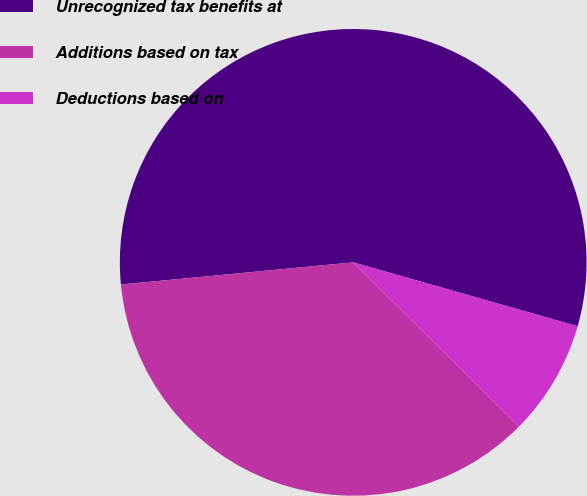Convert chart. <chart><loc_0><loc_0><loc_500><loc_500><pie_chart><fcel>Unrecognized tax benefits at<fcel>Additions based on tax<fcel>Deductions based on<nl><fcel>55.93%<fcel>36.06%<fcel>8.01%<nl></chart> 